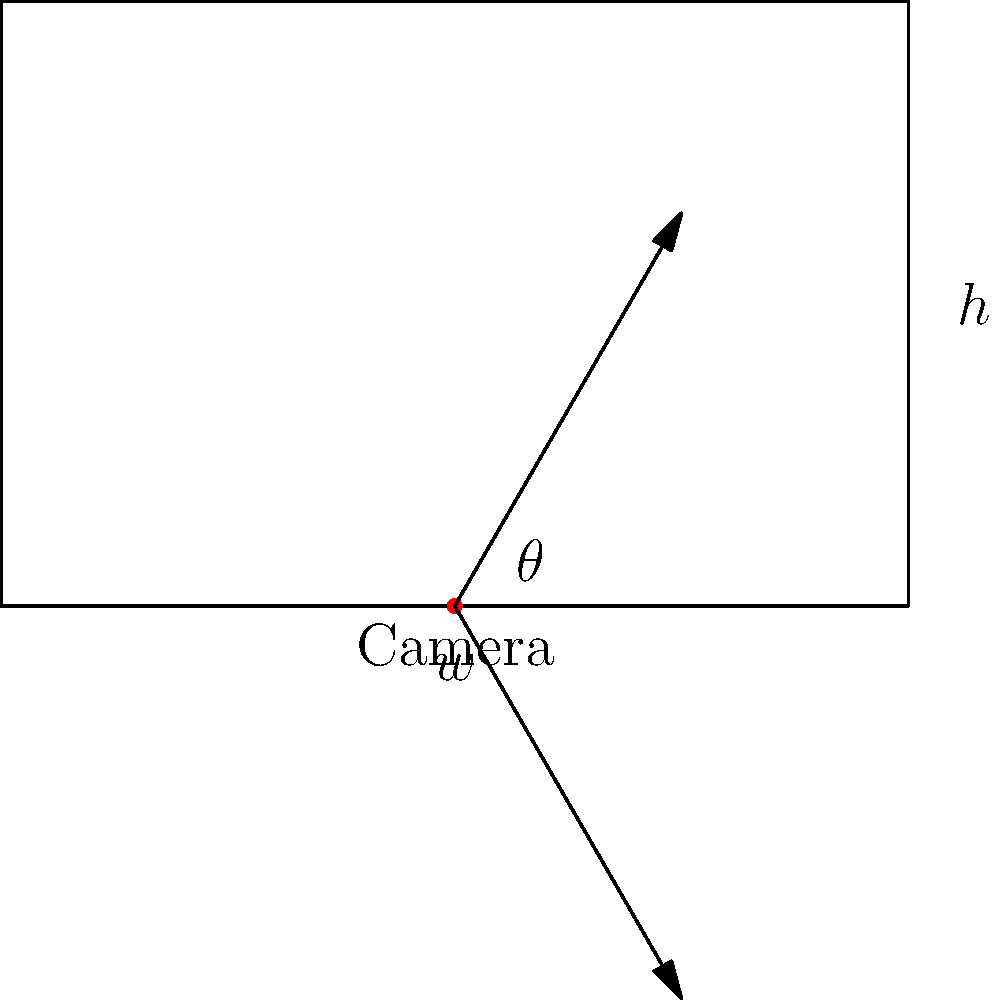A rectangular room with dimensions $w$ (width) and $h$ (height) has a security camera positioned at the center of one of the shorter walls. The camera's field of view is defined by an angle $\theta$. Determine the optimal angle $\theta$ that maximizes the area covered by the camera. Express your answer in terms of $w$ and $h$. To solve this problem, we'll follow these steps:

1) The area covered by the camera forms a triangle. We need to maximize this area.

2) The area of a triangle is given by $A = \frac{1}{2} \cdot base \cdot height$.

3) In this case, the base is the width of the room $w$, and the height is $h - x$, where $x$ is the distance from the camera to where the field of view intersects the opposite wall.

4) We can express $x$ in terms of $w$, $h$, and $\theta$:
   $\tan(\frac{\theta}{2}) = \frac{w/2}{h-x}$

5) Solving for $x$:
   $x = h - \frac{w}{2\tan(\frac{\theta}{2})}$

6) Now, the area $A$ can be expressed as:
   $A = \frac{1}{2} \cdot w \cdot (h - (h - \frac{w}{2\tan(\frac{\theta}{2})}))$
   $A = \frac{w^2}{4\tan(\frac{\theta}{2})}$

7) To find the maximum, we differentiate $A$ with respect to $\theta$ and set it to zero:
   $\frac{dA}{d\theta} = \frac{w^2}{4} \cdot (-\frac{1}{2}) \cdot \sec^2(\frac{\theta}{2}) \cdot (-\frac{1}{2}) = 0$

8) This equation is satisfied when $\sec^2(\frac{\theta}{2}) = 1$, which occurs when $\frac{\theta}{2} = 45°$ or $\theta = 90°$.

9) To confirm this is a maximum, we can check the second derivative or consider the behavior of the function.

10) The optimal angle is therefore $\theta = 90°$, regardless of the room dimensions.

11) We can verify that this makes intuitive sense: a 90° angle allows the camera to see from one corner of the room to the other along the diagonal.
Answer: $90°$ 